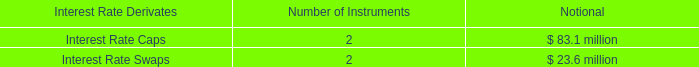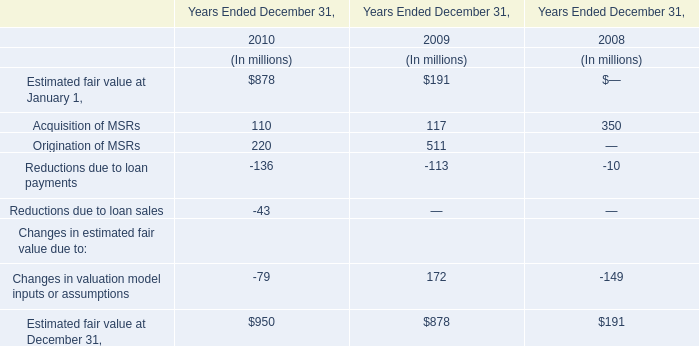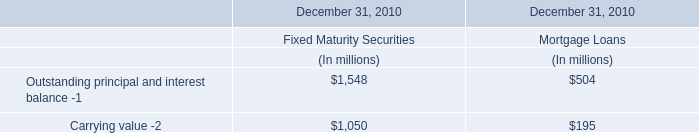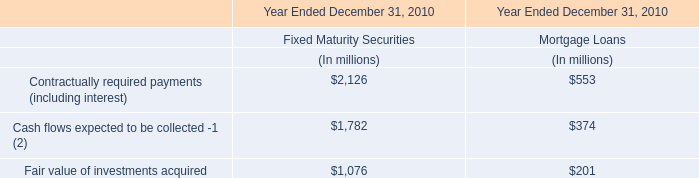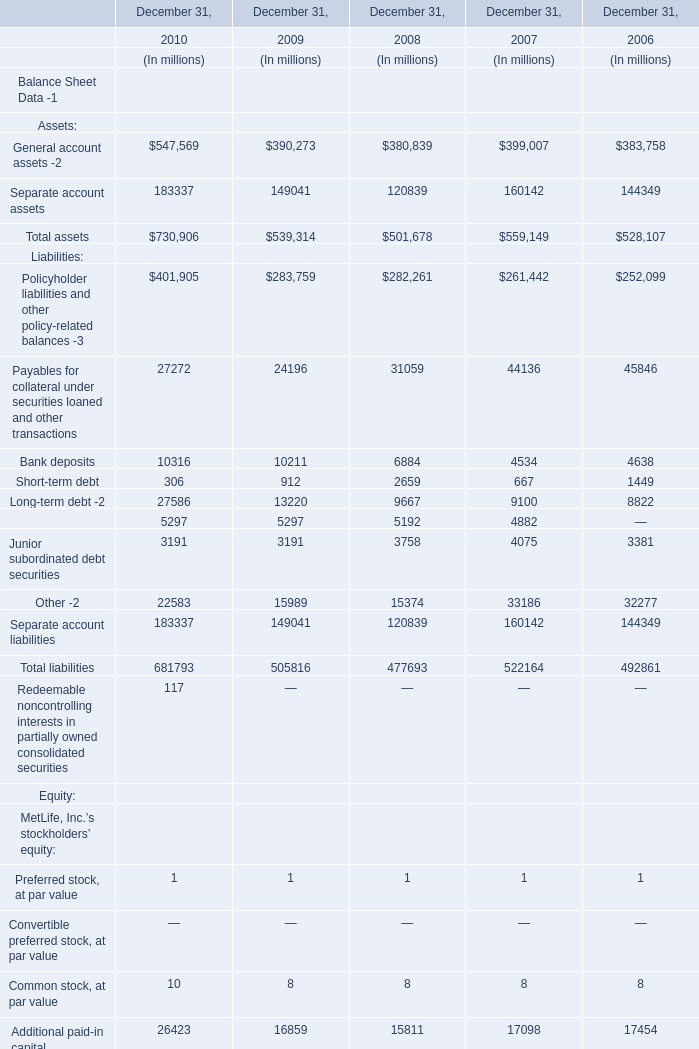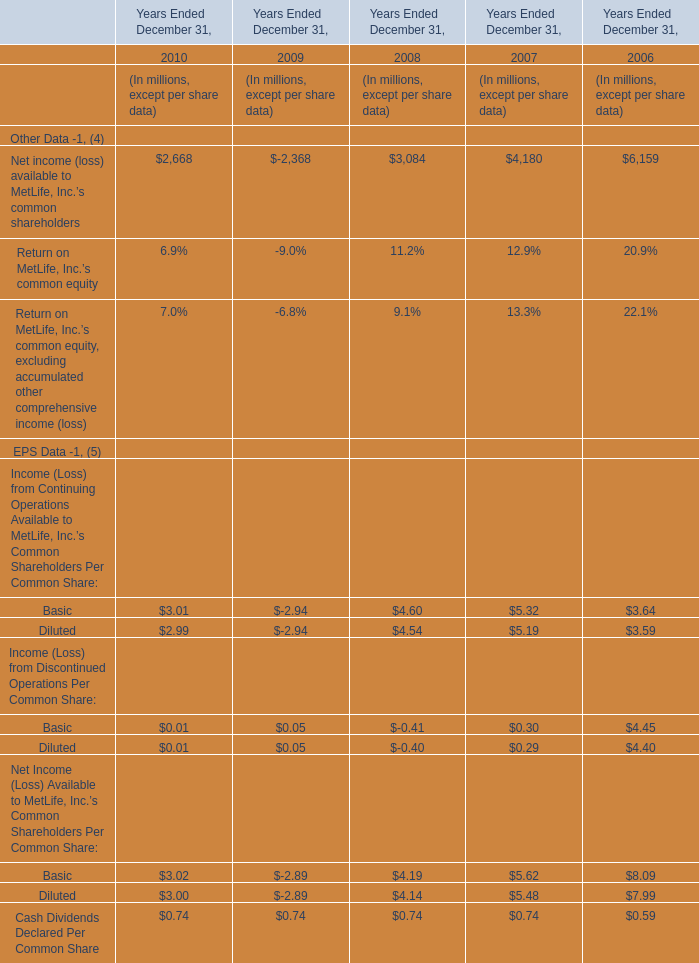In what year is Policyholder liabilities and other policy-related balances -3 greater than 270000? 
Answer: 2008 2009 2010. 